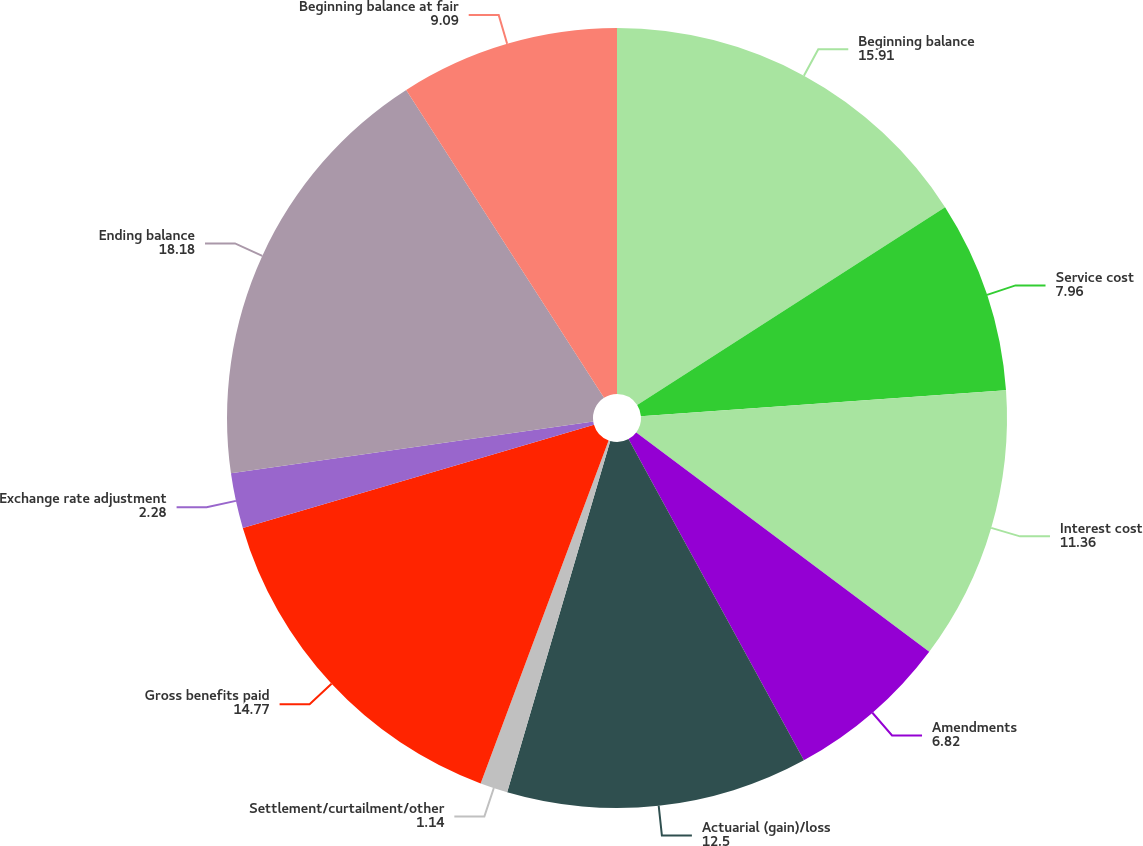<chart> <loc_0><loc_0><loc_500><loc_500><pie_chart><fcel>Beginning balance<fcel>Service cost<fcel>Interest cost<fcel>Amendments<fcel>Actuarial (gain)/loss<fcel>Settlement/curtailment/other<fcel>Gross benefits paid<fcel>Exchange rate adjustment<fcel>Ending balance<fcel>Beginning balance at fair<nl><fcel>15.91%<fcel>7.96%<fcel>11.36%<fcel>6.82%<fcel>12.5%<fcel>1.14%<fcel>14.77%<fcel>2.28%<fcel>18.18%<fcel>9.09%<nl></chart> 